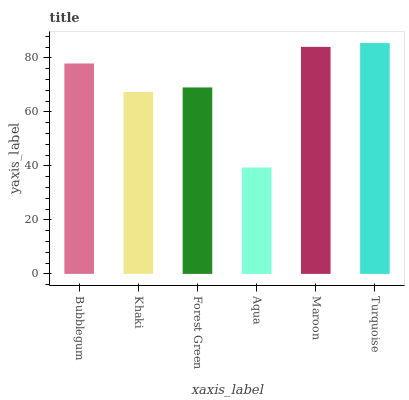Is Aqua the minimum?
Answer yes or no. Yes. Is Turquoise the maximum?
Answer yes or no. Yes. Is Khaki the minimum?
Answer yes or no. No. Is Khaki the maximum?
Answer yes or no. No. Is Bubblegum greater than Khaki?
Answer yes or no. Yes. Is Khaki less than Bubblegum?
Answer yes or no. Yes. Is Khaki greater than Bubblegum?
Answer yes or no. No. Is Bubblegum less than Khaki?
Answer yes or no. No. Is Bubblegum the high median?
Answer yes or no. Yes. Is Forest Green the low median?
Answer yes or no. Yes. Is Turquoise the high median?
Answer yes or no. No. Is Bubblegum the low median?
Answer yes or no. No. 